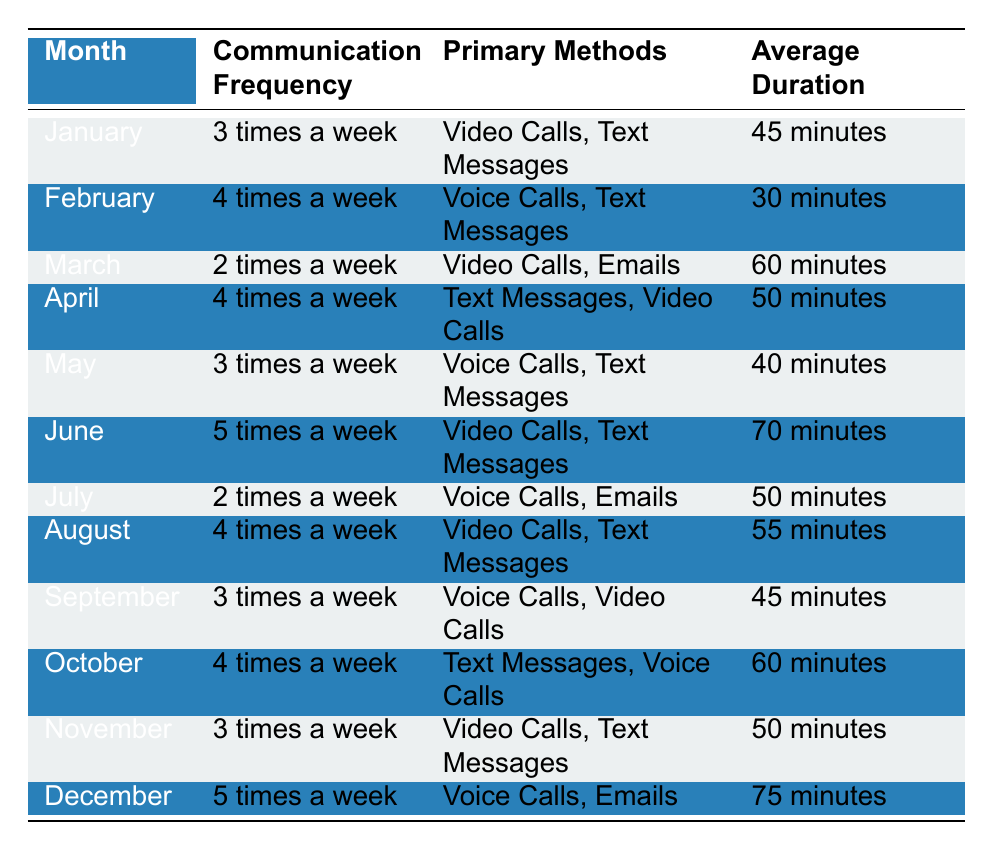What's the communication frequency in June? In the table, June shows a communication frequency listed as "5 times a week."
Answer: 5 times a week Which month had the longest average communication duration? In December, the average duration is recorded as "75 minutes," which is the highest compared to other months.
Answer: 75 minutes How many times a week did they communicate in April compared to October? In April, the communication frequency is "4 times a week," which is the same as in October as well. Both months show the same frequency.
Answer: 4 times a week What were the primary methods of communication in March? According to the table, in March, the primary methods of communication were "Video Calls" and "Emails."
Answer: Video Calls, Emails Was there a month where communication frequency was exactly 2 times a week? Yes, the months of March and July both had a communication frequency listed as "2 times a week."
Answer: Yes What is the average duration across all the months listed? The total duration for each month is: 45 + 30 + 60 + 50 + 40 + 70 + 50 + 55 + 45 + 60 + 50 + 75 = 685 minutes. There are 12 months, so the average duration is 685/12 ≈ 57.08 minutes.
Answer: 57.08 minutes In which month did voice calls become the primary communication method? Voice Calls were a primary method in February (alongside Text Messages), May (alongside Text Messages), July (alongside Emails), September (alongside Video Calls), October (alongside Text Messages), and December (alongside Emails).
Answer: February, May, July, September, October, December What is the trend in communication frequency over the year? The communication frequency fluctuated throughout the year, with increases and decreases noted. Specifically, June had the highest at "5 times a week," meanwhile March and July had the lowest at "2 times a week."
Answer: Fluctuating trend 